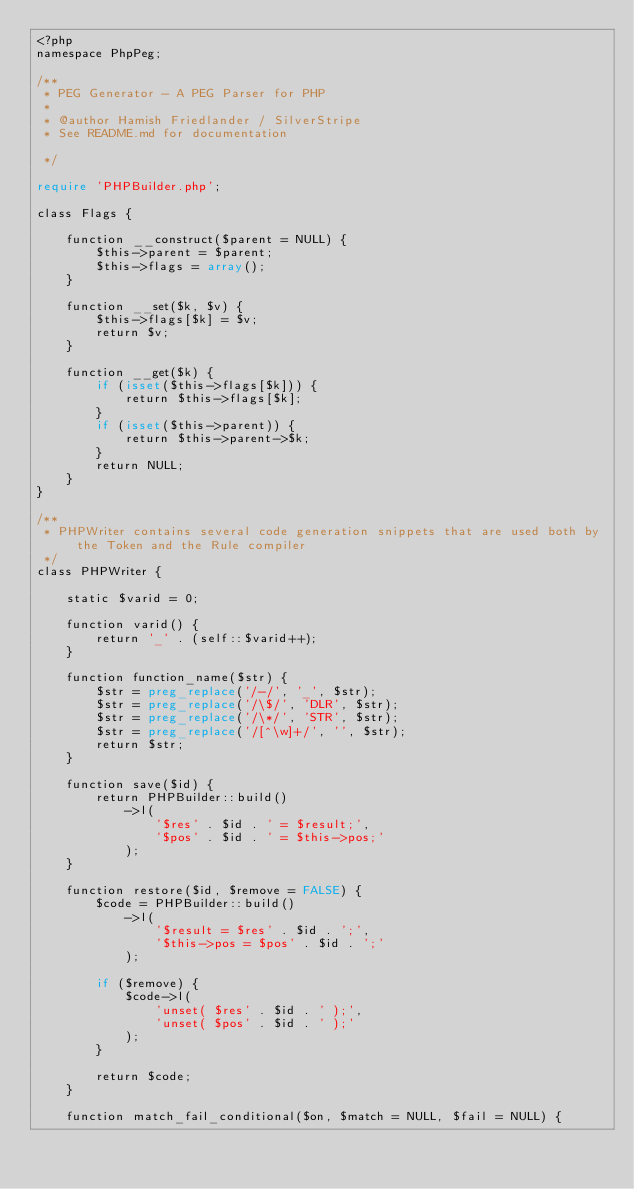Convert code to text. <code><loc_0><loc_0><loc_500><loc_500><_PHP_><?php
namespace PhpPeg;

/**
 * PEG Generator - A PEG Parser for PHP
 *
 * @author Hamish Friedlander / SilverStripe
 * See README.md for documentation

 */

require 'PHPBuilder.php';

class Flags {

	function __construct($parent = NULL) {
		$this->parent = $parent;
		$this->flags = array();
	}

	function __set($k, $v) {
		$this->flags[$k] = $v;
		return $v;
	}

	function __get($k) {
		if (isset($this->flags[$k])) {
			return $this->flags[$k];
		}
		if (isset($this->parent)) {
			return $this->parent->$k;
		}
		return NULL;
	}
}

/**
 * PHPWriter contains several code generation snippets that are used both by the Token and the Rule compiler
 */
class PHPWriter {

	static $varid = 0;

	function varid() {
		return '_' . (self::$varid++);
	}

	function function_name($str) {
		$str = preg_replace('/-/', '_', $str);
		$str = preg_replace('/\$/', 'DLR', $str);
		$str = preg_replace('/\*/', 'STR', $str);
		$str = preg_replace('/[^\w]+/', '', $str);
		return $str;
	}

	function save($id) {
		return PHPBuilder::build()
			->l(
				'$res' . $id . ' = $result;',
				'$pos' . $id . ' = $this->pos;'
			);
	}

	function restore($id, $remove = FALSE) {
		$code = PHPBuilder::build()
			->l(
				'$result = $res' . $id . ';',
				'$this->pos = $pos' . $id . ';'
			);

		if ($remove) {
			$code->l(
				'unset( $res' . $id . ' );',
				'unset( $pos' . $id . ' );'
			);
		}

		return $code;
	}

	function match_fail_conditional($on, $match = NULL, $fail = NULL) {</code> 